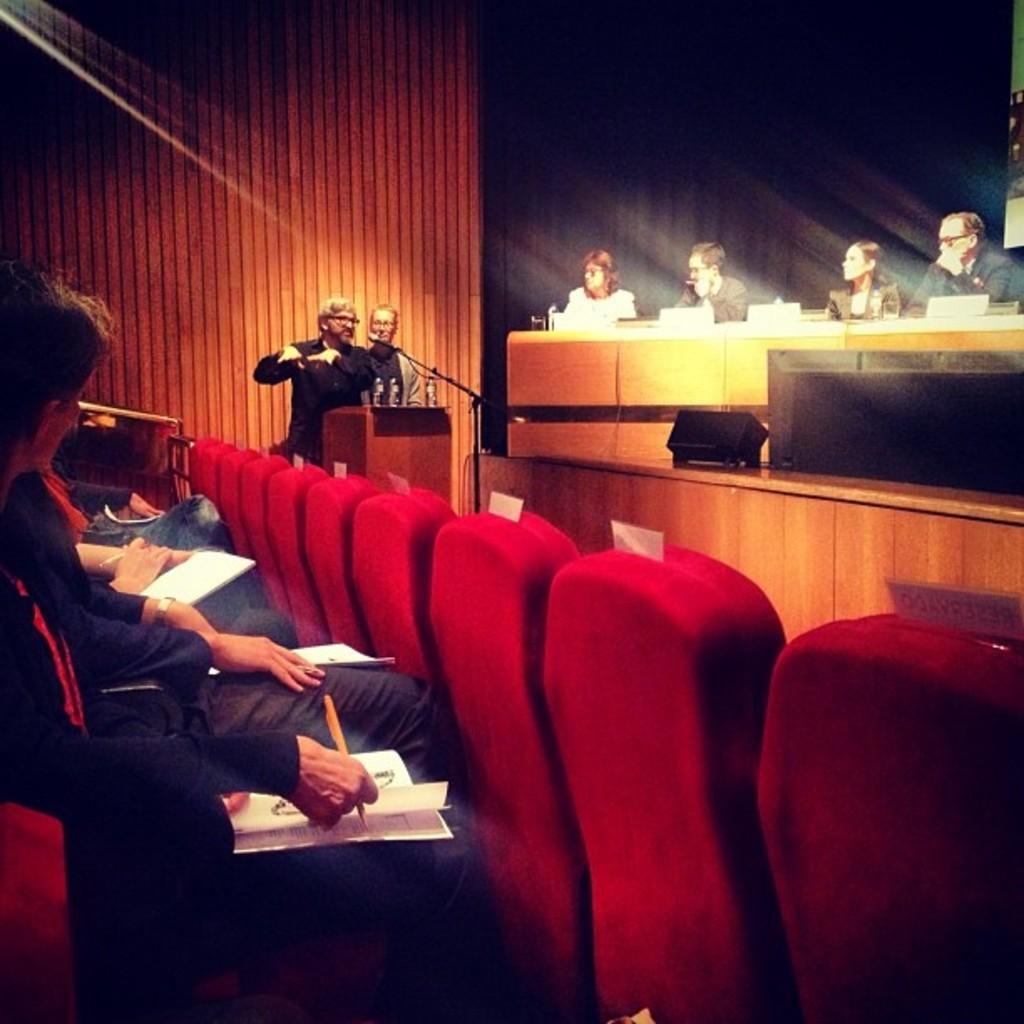Please provide a concise description of this image. A man at a podium is speaking with some people on either side are listening to him. 